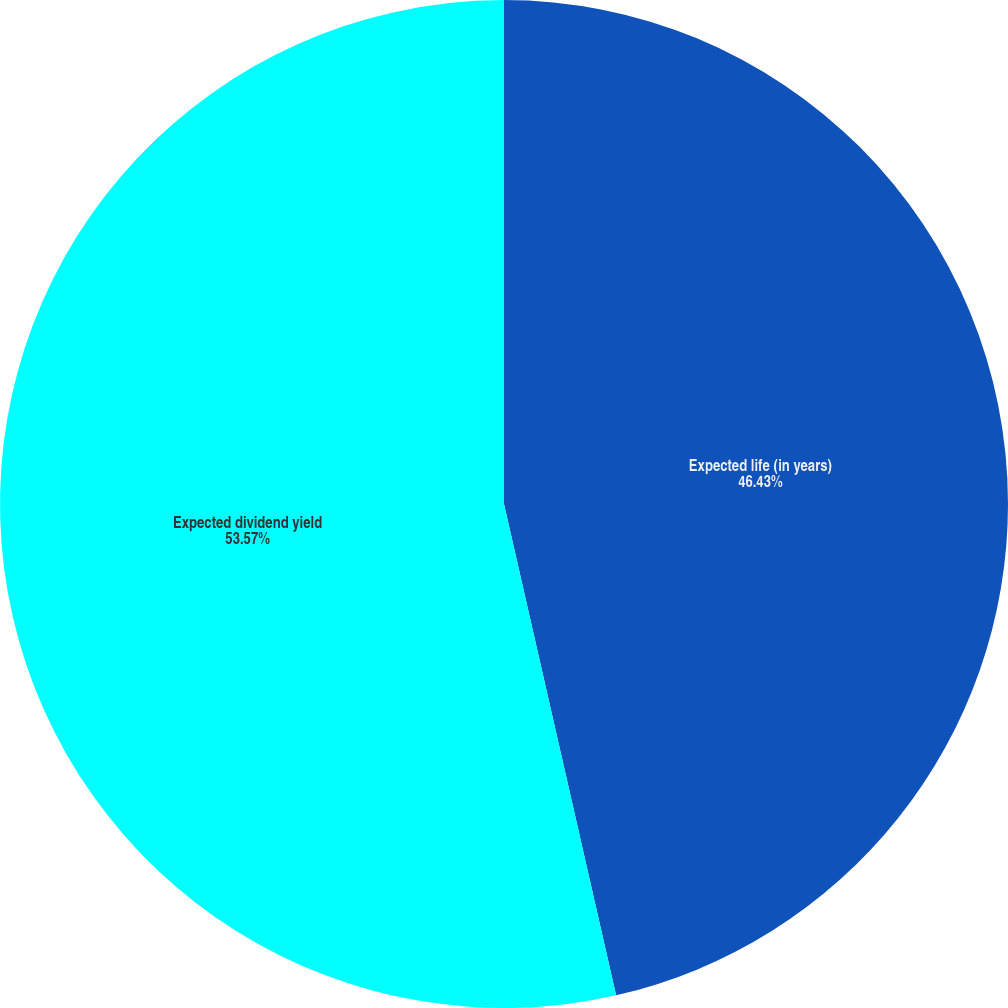<chart> <loc_0><loc_0><loc_500><loc_500><pie_chart><fcel>Expected life (in years)<fcel>Expected dividend yield<nl><fcel>46.43%<fcel>53.57%<nl></chart> 